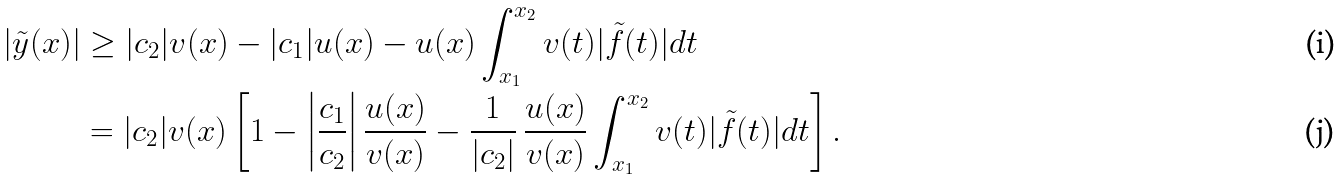Convert formula to latex. <formula><loc_0><loc_0><loc_500><loc_500>| \tilde { y } ( x ) | & \geq | c _ { 2 } | v ( x ) - | c _ { 1 } | u ( x ) - u ( x ) \int _ { x _ { 1 } } ^ { x _ { 2 } } v ( t ) | \tilde { f } ( t ) | d t \\ & = | c _ { 2 } | v ( x ) \left [ 1 - \left | \frac { c _ { 1 } } { c _ { 2 } } \right | \frac { u ( x ) } { v ( x ) } - \frac { 1 } { | c _ { 2 } | } \ \frac { u ( x ) } { v ( x ) } \int _ { x _ { 1 } } ^ { x _ { 2 } } v ( t ) | \tilde { f } ( t ) | d t \right ] .</formula> 